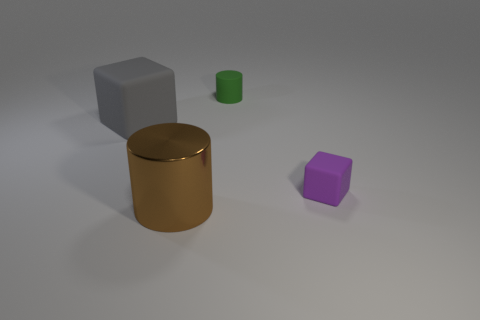What shapes can you identify in the image? The image contains a variety of geometric shapes. There's a large vertical cylinder in the center with what looks to be a metallic surface. To its left, there's a cube with a matte surface. On the right side of the cylinder, there is a smaller cylinder with a green tint, and further right, a small purple object resembling a cube but with more height, potentially a rectangular prism. 